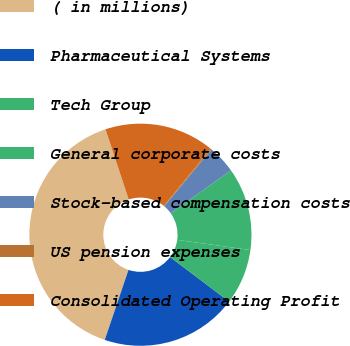Convert chart to OTSL. <chart><loc_0><loc_0><loc_500><loc_500><pie_chart><fcel>( in millions)<fcel>Pharmaceutical Systems<fcel>Tech Group<fcel>General corporate costs<fcel>Stock-based compensation costs<fcel>US pension expenses<fcel>Consolidated Operating Profit<nl><fcel>39.7%<fcel>19.93%<fcel>8.07%<fcel>12.03%<fcel>4.12%<fcel>0.17%<fcel>15.98%<nl></chart> 